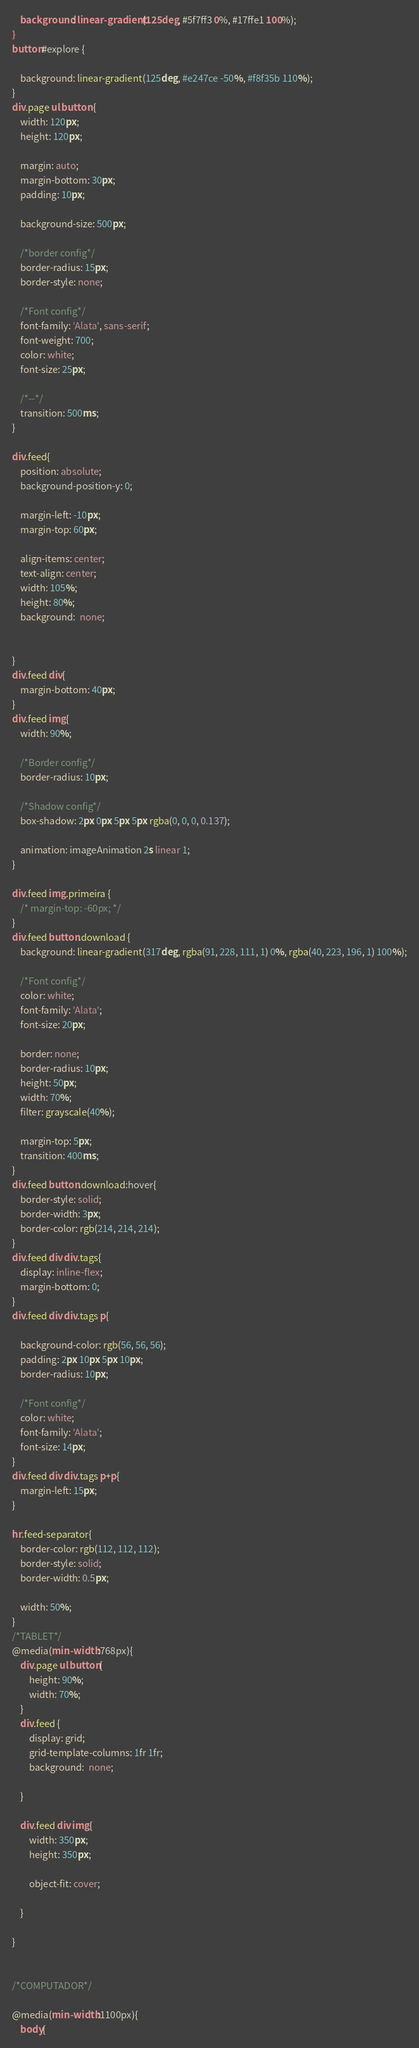Convert code to text. <code><loc_0><loc_0><loc_500><loc_500><_CSS_>    background: linear-gradient(125deg, #5f7ff3 0%, #17ffe1 100%);
}
button#explore {
    
    background: linear-gradient(125deg, #e247ce -50%, #f8f35b 110%);
}
div.page ul button {
    width: 120px;
    height: 120px;
    
    margin: auto;
    margin-bottom: 30px;
    padding: 10px;
    
    background-size: 500px;
    
    /*border config*/
    border-radius: 15px;
    border-style: none;

    /*Font config*/
    font-family: 'Alata', sans-serif;
    font-weight: 700;
    color: white;
    font-size: 25px;

    /*--*/
    transition: 500ms;
}

div.feed{
    position: absolute;
    background-position-y: 0;
    
    margin-left: -10px;
    margin-top: 60px;

    align-items: center;
    text-align: center;
    width: 105%;
    height: 80%;
    background:  none;

      
}
div.feed div{
    margin-bottom: 40px;
}
div.feed img{
    width: 90%;

    /*Border config*/
    border-radius: 10px;

    /*Shadow config*/
    box-shadow: 2px 0px 5px 5px rgba(0, 0, 0, 0.137);

    animation: imageAnimation 2s linear 1;
}

div.feed img.primeira {
    /* margin-top: -60px; */
}
div.feed button.download {
    background: linear-gradient(317deg, rgba(91, 228, 111, 1) 0%, rgba(40, 223, 196, 1) 100%);

    /*Font config*/
    color: white;
    font-family: 'Alata';
    font-size: 20px;

    border: none;
    border-radius: 10px;
    height: 50px;
    width: 70%;
    filter: grayscale(40%);

    margin-top: 5px;
    transition: 400ms;
}
div.feed button.download:hover{
    border-style: solid;
    border-width: 3px;
    border-color: rgb(214, 214, 214);
}
div.feed div div.tags{
    display: inline-flex;
    margin-bottom: 0;
}
div.feed div div.tags p{
    
    background-color: rgb(56, 56, 56);
    padding: 2px 10px 5px 10px;
    border-radius: 10px;
    
    /*Font config*/
    color: white;
    font-family: 'Alata';
    font-size: 14px;
}
div.feed div div.tags p+p{
    margin-left: 15px;
}

hr.feed-separator{
    border-color: rgb(112, 112, 112);
    border-style: solid;
    border-width: 0.5px;
    
    width: 50%;
}
/*TABLET*/
@media(min-width:768px){
    div.page ul button{
        height: 90%;
        width: 70%;
    }
    div.feed {
        display: grid;
        grid-template-columns: 1fr 1fr;
        background:  none;

    }
   
    div.feed div img{
        width: 350px;
        height: 350px;

        object-fit: cover;

    }

}


/*COMPUTADOR*/

@media(min-width:1100px){
    body{</code> 